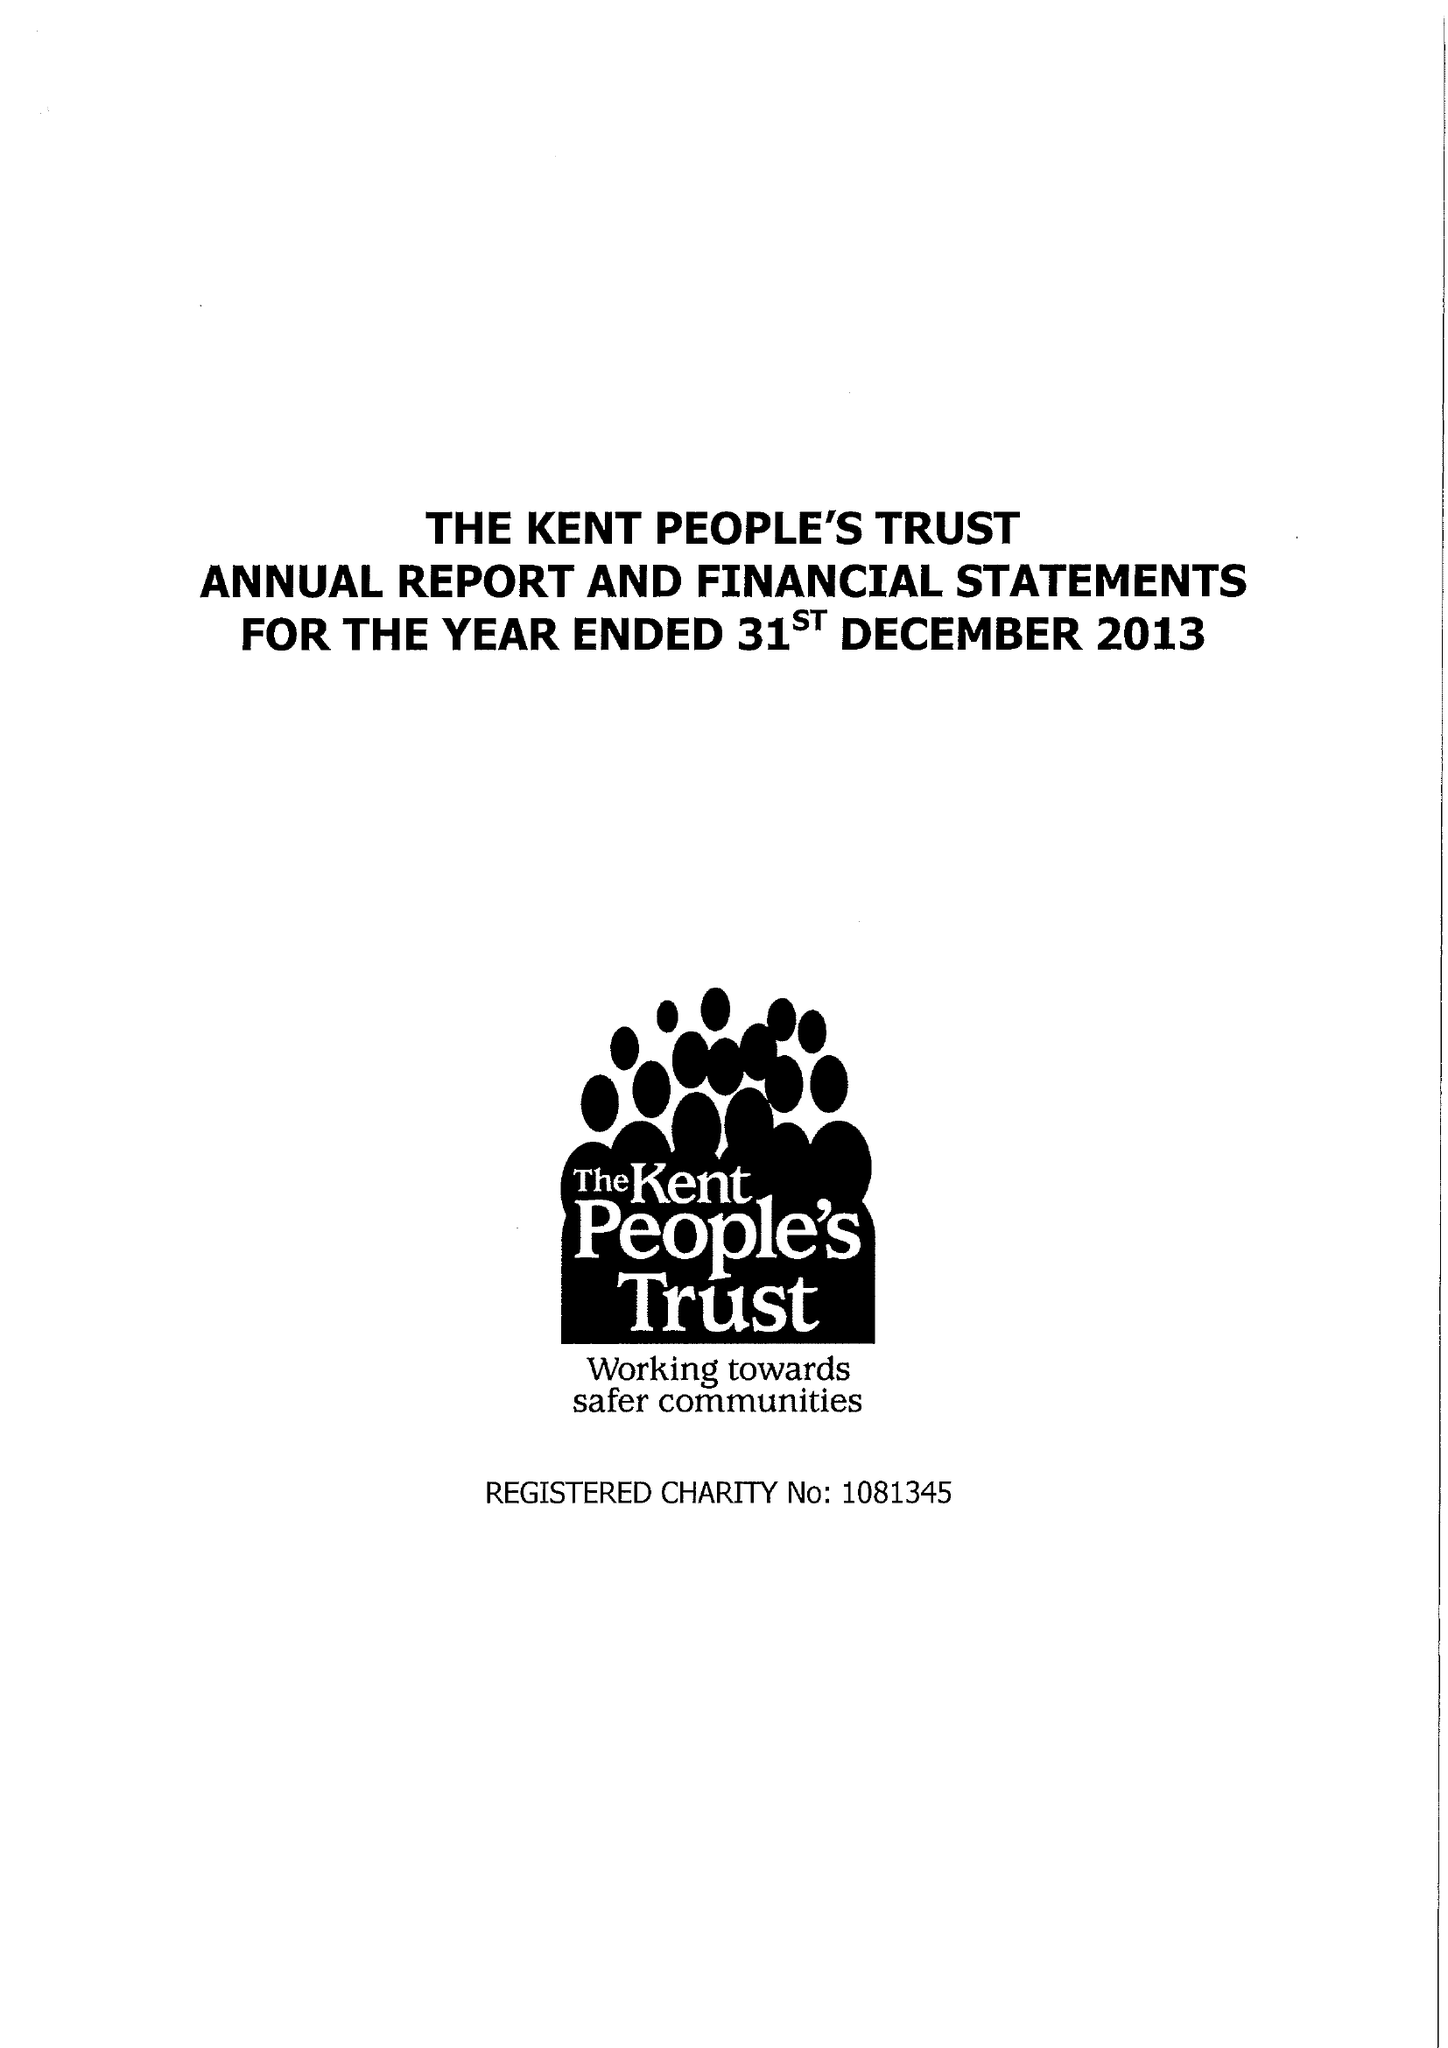What is the value for the spending_annually_in_british_pounds?
Answer the question using a single word or phrase. 139752.00 